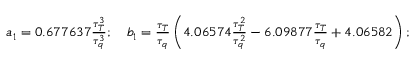Convert formula to latex. <formula><loc_0><loc_0><loc_500><loc_500>\begin{array} { r } { a _ { 1 } = 0 . 6 7 7 6 3 7 \frac { \tau _ { T } ^ { 3 } } { \tau _ { q } ^ { 3 } } ; \quad b _ { 1 } = \frac { \tau _ { T } } { \tau _ { q } } \left ( 4 . 0 6 5 7 4 \frac { \tau _ { T } ^ { 2 } } { \tau _ { q } ^ { 2 } } - 6 . 0 9 8 7 7 \frac { \tau _ { T } } { \tau _ { q } } + 4 . 0 6 5 8 2 \right ) ; } \end{array}</formula> 